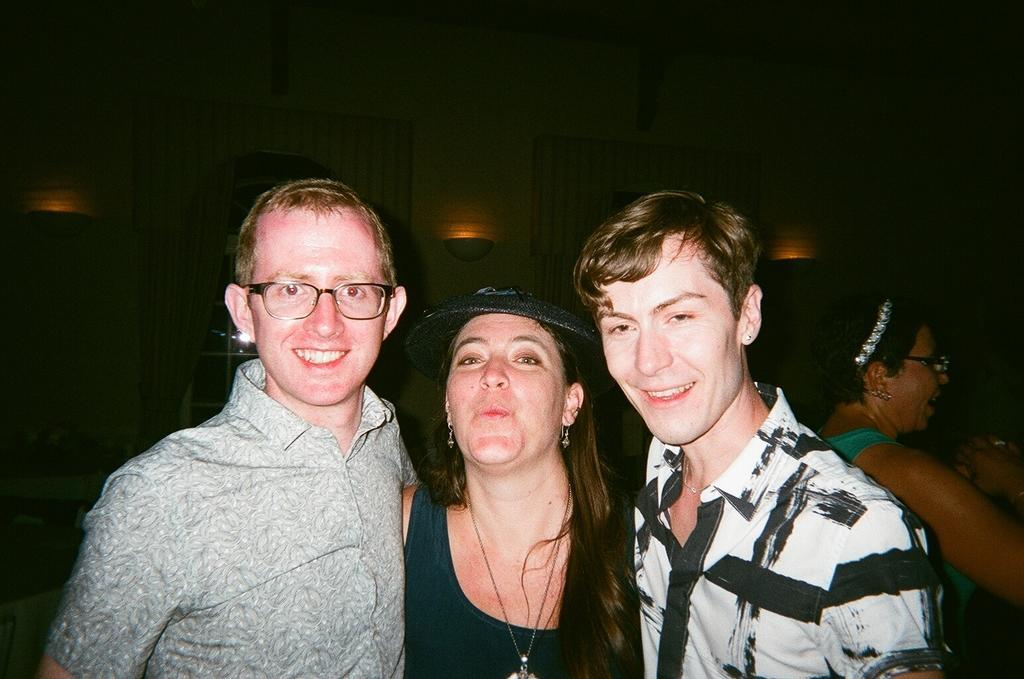How would you summarize this image in a sentence or two? In the image we can see there are people wearing clothes and these people are smiling, this is a neck chain, earring, hat, spectacles, hair belt and these are the lights, these are the windows and curtains. 